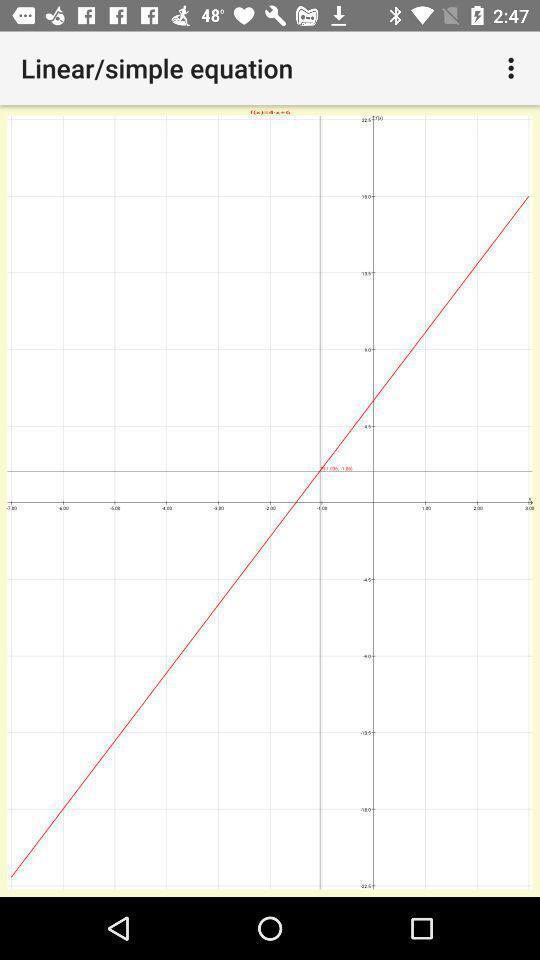What can you discern from this picture? Screen showing the graph of an equation. 